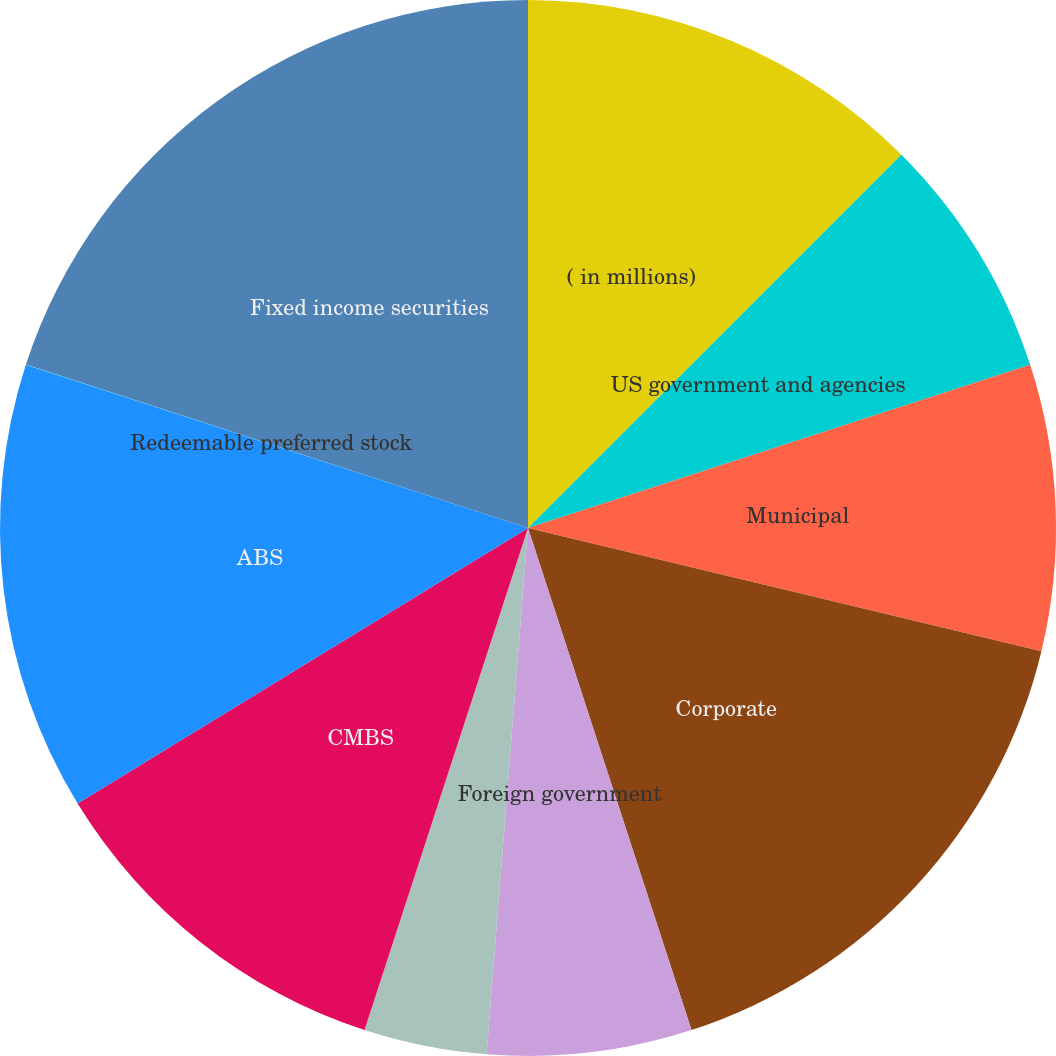Convert chart to OTSL. <chart><loc_0><loc_0><loc_500><loc_500><pie_chart><fcel>( in millions)<fcel>US government and agencies<fcel>Municipal<fcel>Corporate<fcel>Foreign government<fcel>MBS<fcel>CMBS<fcel>ABS<fcel>Redeemable preferred stock<fcel>Fixed income securities<nl><fcel>12.5%<fcel>7.5%<fcel>8.75%<fcel>16.24%<fcel>6.26%<fcel>3.76%<fcel>11.25%<fcel>13.74%<fcel>0.01%<fcel>19.99%<nl></chart> 